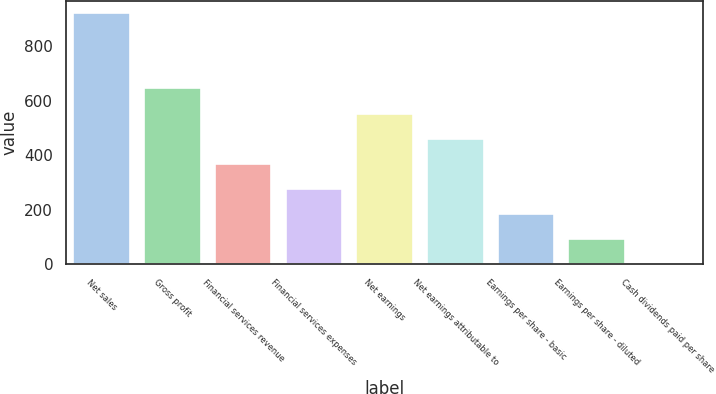<chart> <loc_0><loc_0><loc_500><loc_500><bar_chart><fcel>Net sales<fcel>Gross profit<fcel>Financial services revenue<fcel>Financial services expenses<fcel>Net earnings<fcel>Net earnings attributable to<fcel>Earnings per share - basic<fcel>Earnings per share - diluted<fcel>Cash dividends paid per share<nl><fcel>921.4<fcel>645.2<fcel>368.99<fcel>276.92<fcel>553.13<fcel>461.06<fcel>184.85<fcel>92.78<fcel>0.71<nl></chart> 